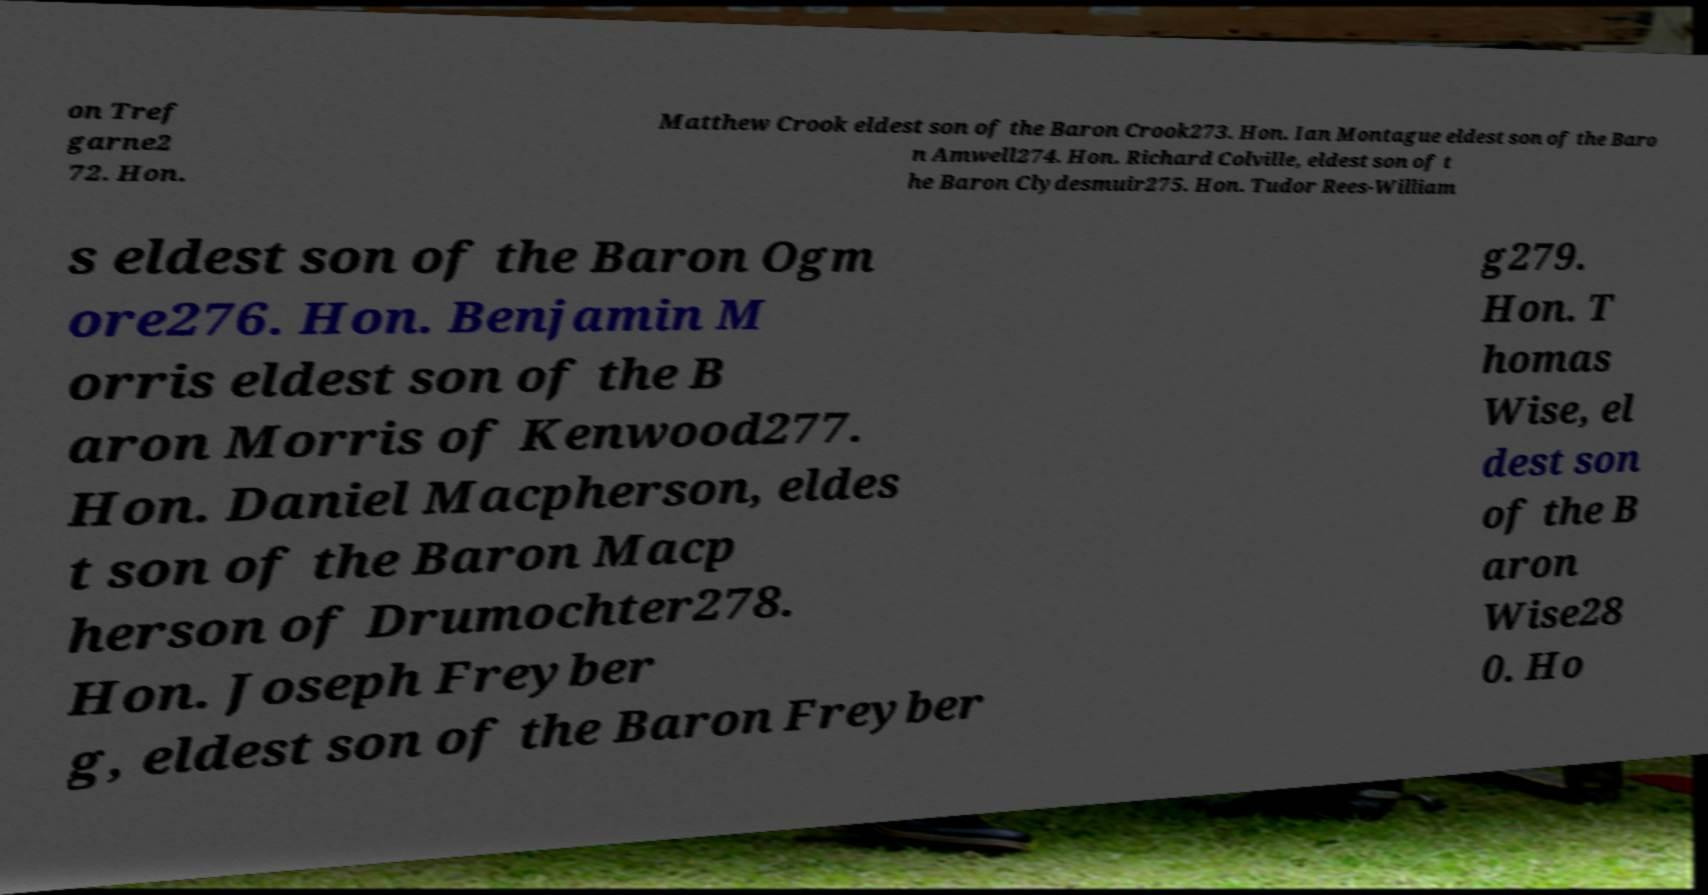I need the written content from this picture converted into text. Can you do that? on Tref garne2 72. Hon. Matthew Crook eldest son of the Baron Crook273. Hon. Ian Montague eldest son of the Baro n Amwell274. Hon. Richard Colville, eldest son of t he Baron Clydesmuir275. Hon. Tudor Rees-William s eldest son of the Baron Ogm ore276. Hon. Benjamin M orris eldest son of the B aron Morris of Kenwood277. Hon. Daniel Macpherson, eldes t son of the Baron Macp herson of Drumochter278. Hon. Joseph Freyber g, eldest son of the Baron Freyber g279. Hon. T homas Wise, el dest son of the B aron Wise28 0. Ho 